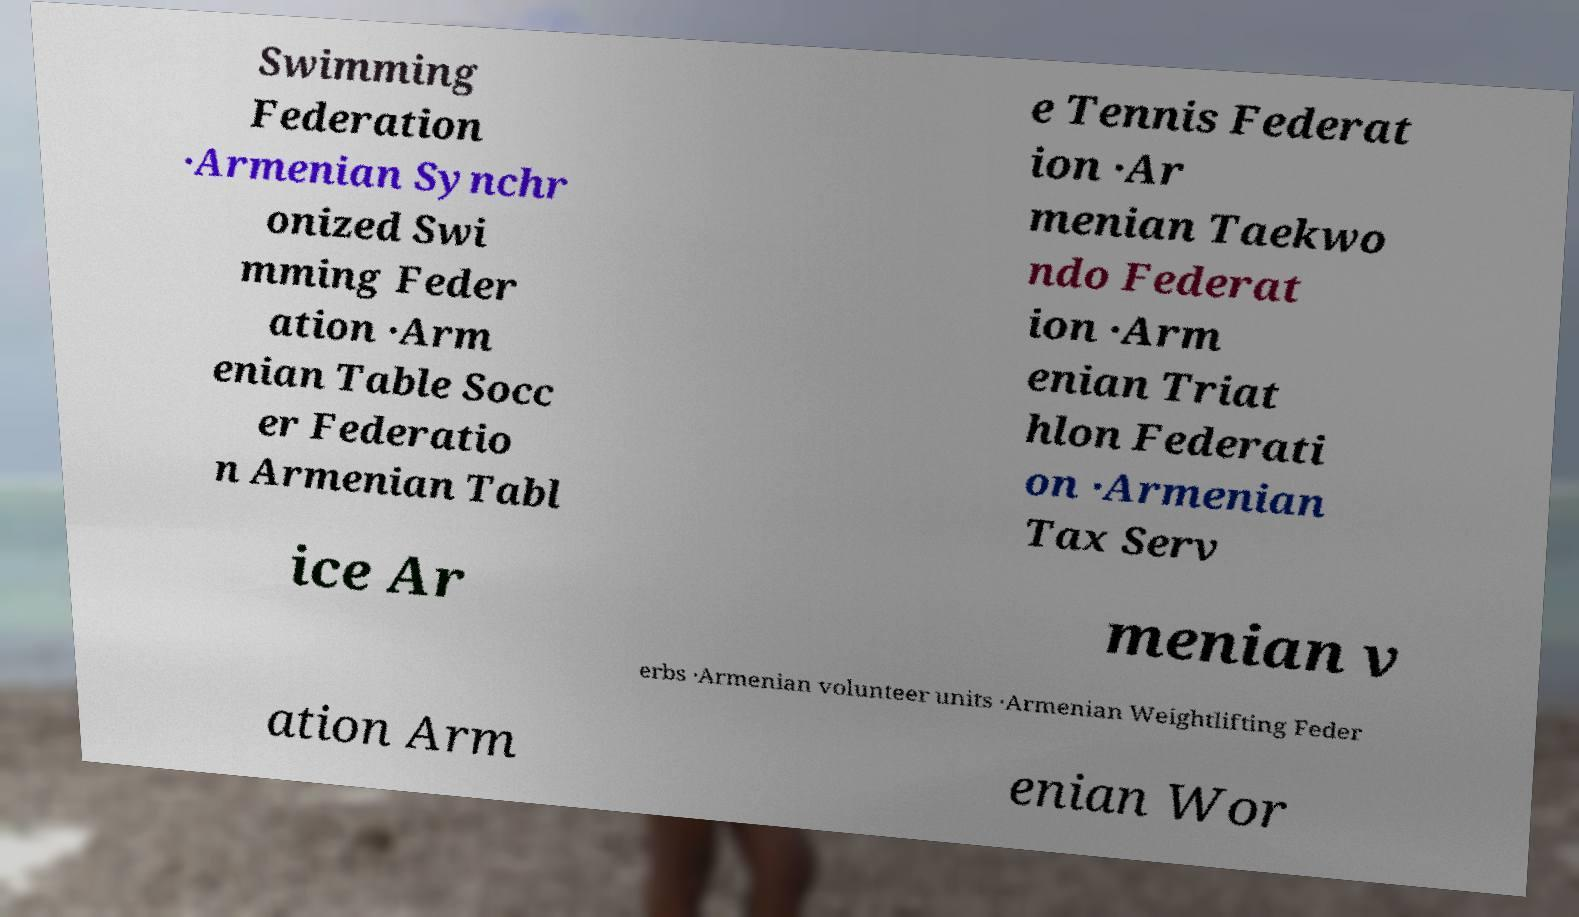Can you read and provide the text displayed in the image?This photo seems to have some interesting text. Can you extract and type it out for me? Swimming Federation ·Armenian Synchr onized Swi mming Feder ation ·Arm enian Table Socc er Federatio n Armenian Tabl e Tennis Federat ion ·Ar menian Taekwo ndo Federat ion ·Arm enian Triat hlon Federati on ·Armenian Tax Serv ice Ar menian v erbs ·Armenian volunteer units ·Armenian Weightlifting Feder ation Arm enian Wor 